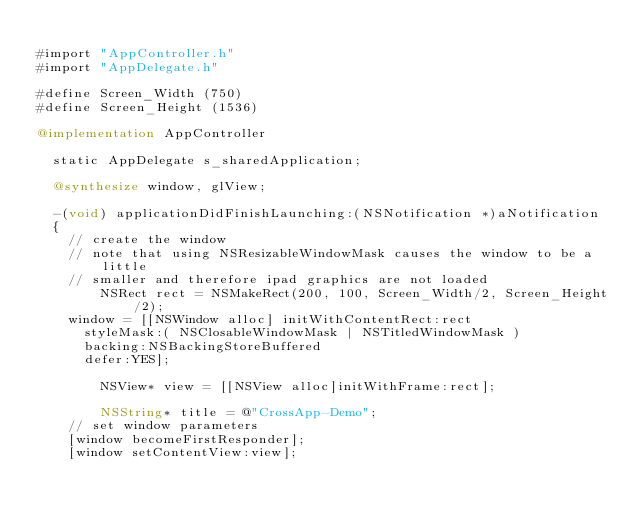Convert code to text. <code><loc_0><loc_0><loc_500><loc_500><_ObjectiveC_> 
#import "AppController.h"
#import "AppDelegate.h"

#define Screen_Width (750)
#define Screen_Height (1536)

@implementation AppController

	static AppDelegate s_sharedApplication;

	@synthesize window, glView;

	-(void) applicationDidFinishLaunching:(NSNotification *)aNotification
	{
		// create the window
		// note that using NSResizableWindowMask causes the window to be a little
		// smaller and therefore ipad graphics are not loaded
        NSRect rect = NSMakeRect(200, 100, Screen_Width/2, Screen_Height/2);
		window = [[NSWindow alloc] initWithContentRect:rect
			styleMask:( NSClosableWindowMask | NSTitledWindowMask )
			backing:NSBackingStoreBuffered
			defer:YES];

        NSView* view = [[NSView alloc]initWithFrame:rect];

        NSString* title = @"CrossApp-Demo";
		// set window parameters
		[window becomeFirstResponder];
		[window setContentView:view];</code> 